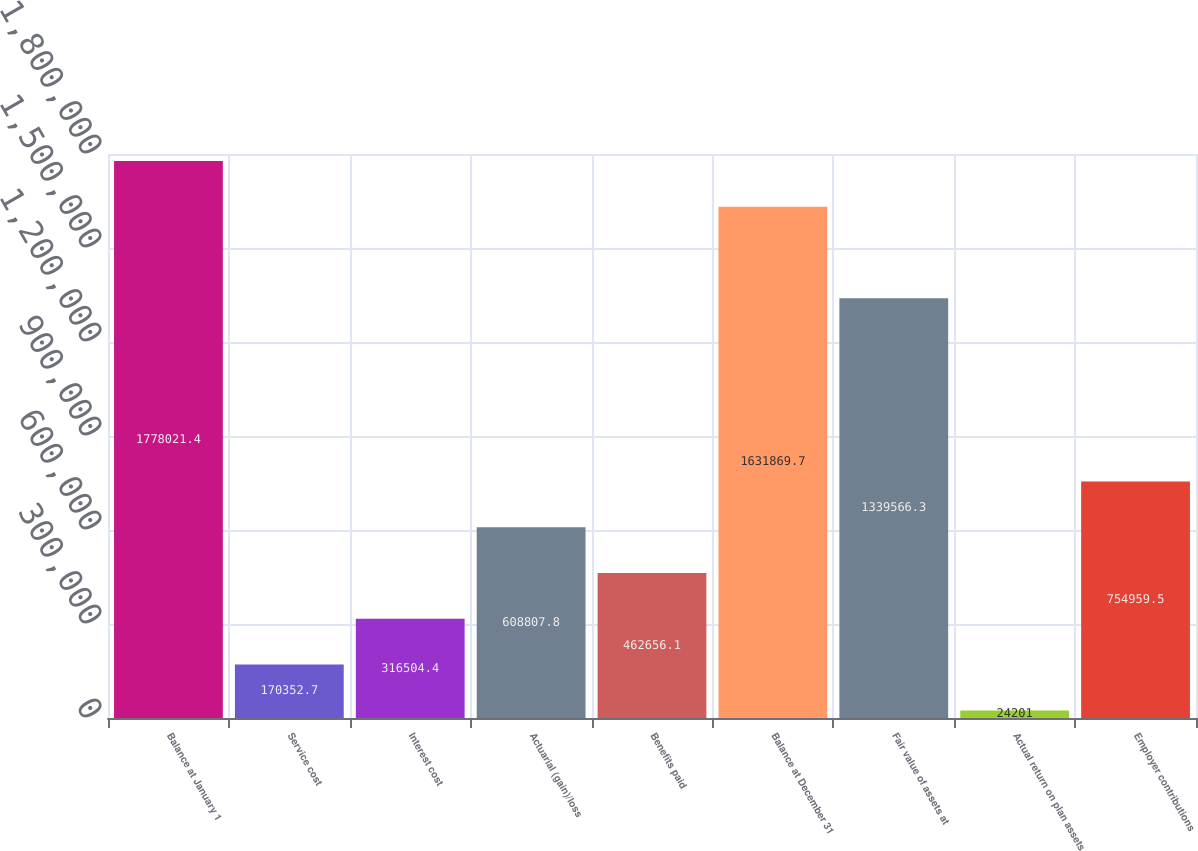<chart> <loc_0><loc_0><loc_500><loc_500><bar_chart><fcel>Balance at January 1<fcel>Service cost<fcel>Interest cost<fcel>Actuarial (gain)/loss<fcel>Benefits paid<fcel>Balance at December 31<fcel>Fair value of assets at<fcel>Actual return on plan assets<fcel>Employer contributions<nl><fcel>1.77802e+06<fcel>170353<fcel>316504<fcel>608808<fcel>462656<fcel>1.63187e+06<fcel>1.33957e+06<fcel>24201<fcel>754960<nl></chart> 